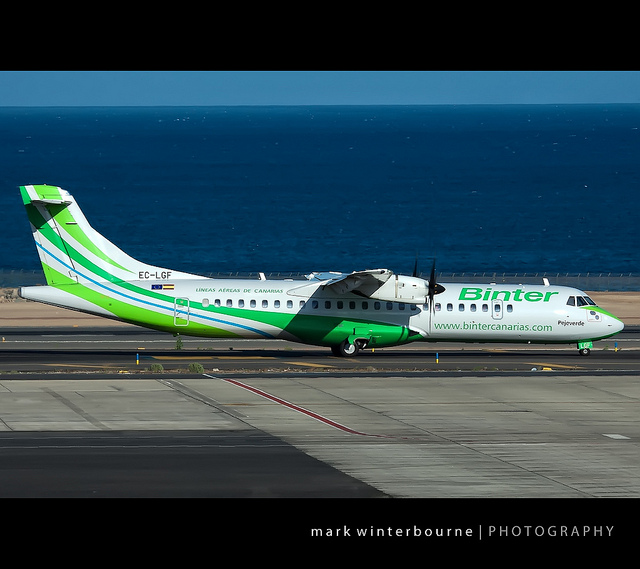Read all the text in this image. EC LGF Binter www.bintercanarias.com PHOTOGRAPHY winterbourne mark 